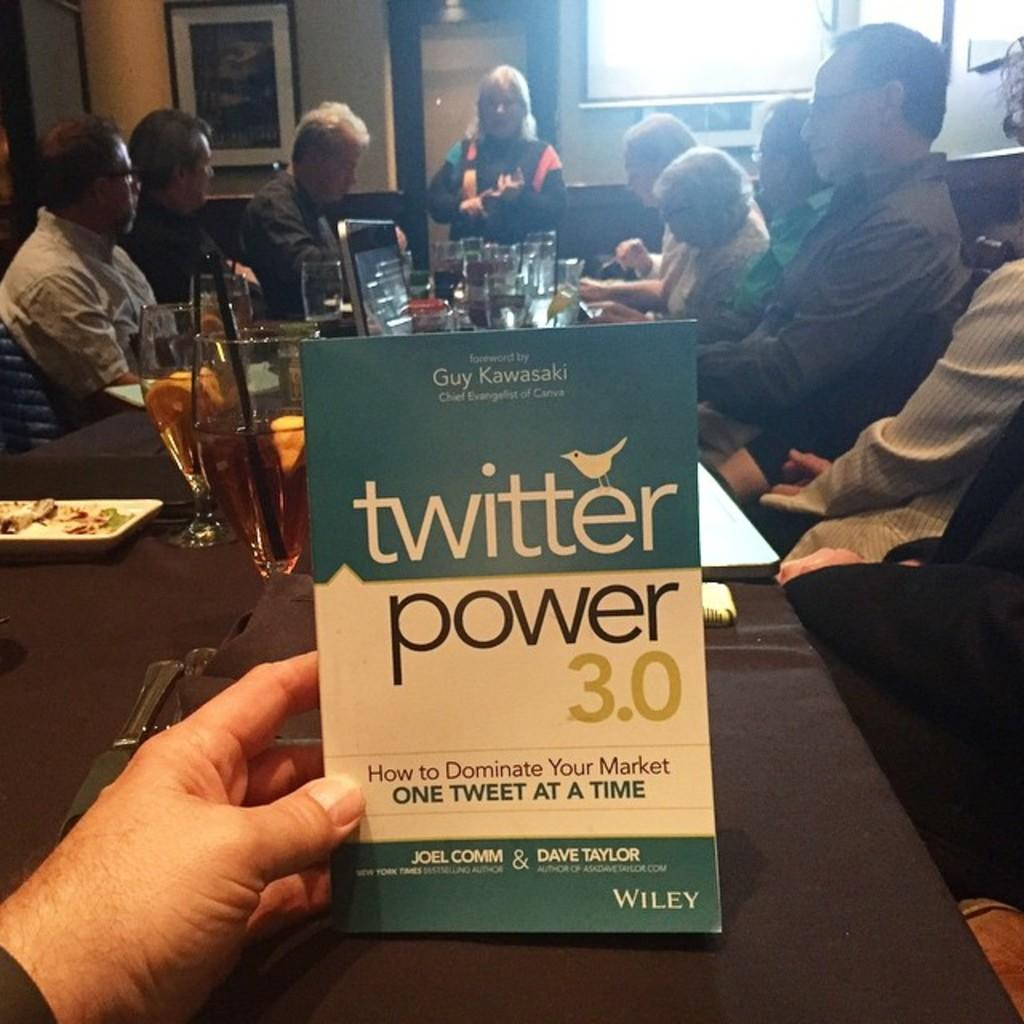<image>
Give a short and clear explanation of the subsequent image. a person looking at a twitter power 3.0 book 